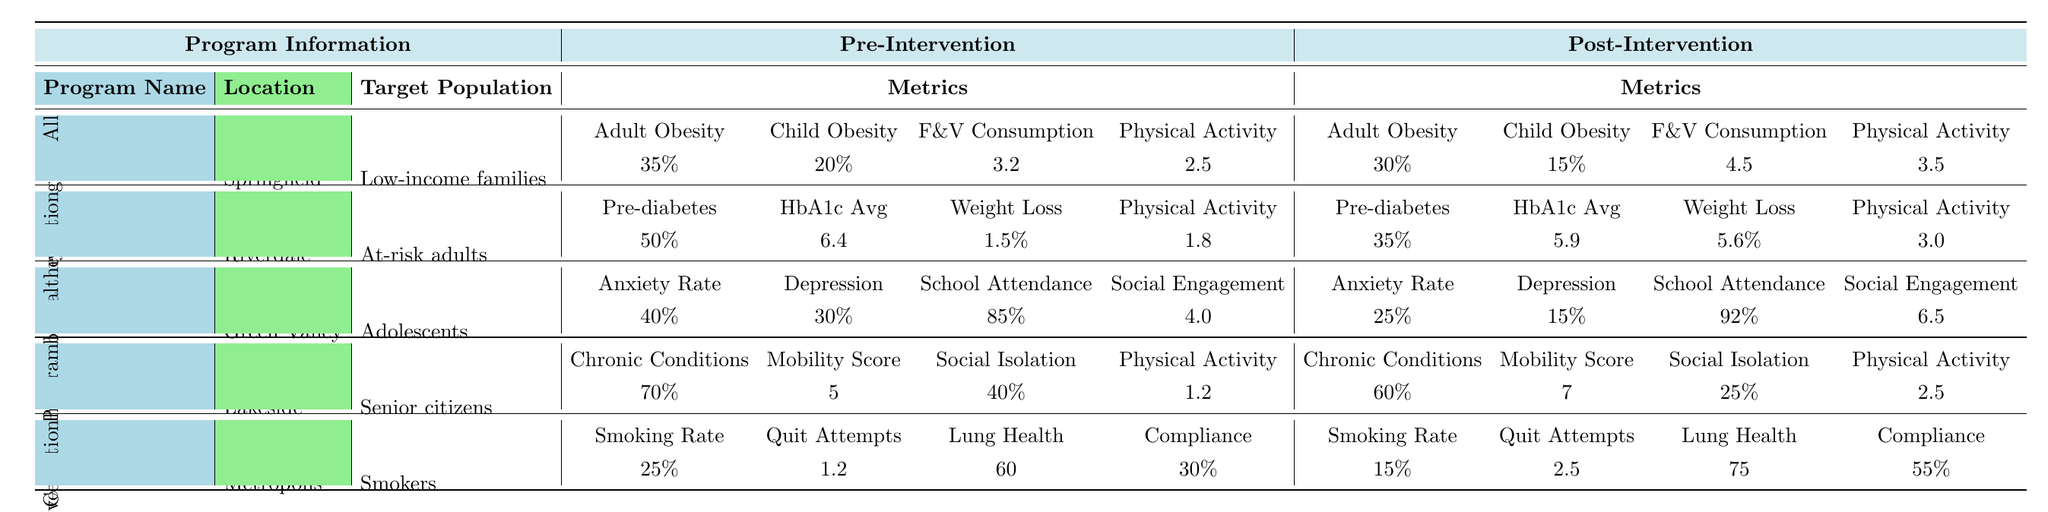What is the smoking rate before the Tobacco Cessation Initiative? The table shows the pre-intervention smoking rate for the Tobacco Cessation Initiative listed under "Pre-Intervention" metrics as 25%.
Answer: 25% What is the average physical activity level for participants in the Healthy Eating for All program after the intervention? In the table, the post-intervention physical activity level for the Healthy Eating for All program is 3.5, which is the only value needed to answer this question.
Answer: 3.5 Did the diabetes prevention program successfully reduce the pre-diabetes rate? The pre-diabetes rate went from 50% before the intervention to 35% afterwards, indicating a successful reduction.
Answer: Yes What was the change in child obesity rate from the Healthy Eating for All program? The child obesity rate decreased from 20% to 15%, so the change is 20% - 15% = 5%.
Answer: 5% Which program had the highest reduction in anxiety rate among adolescents? The Youth Mental Health Initiative had a reduction from 40% to 25%, a 15% decrease. No other program for adolescents is listed with a reduction.
Answer: Youth Mental Health Initiative What is the total percentage of chronic conditions for senior citizens after the Active Aging Program? The post-intervention chronic conditions rate is 60%, which is stated clearly in the table and is the only figure needed.
Answer: 60% Compare the fruit and vegetable consumption before and after the Healthy Eating for All program. The pre-intervention fruit and vegetable consumption was 3.2 servings, which improved to 4.5 servings post-intervention, leading to an increase of 4.5 - 3.2 = 1.3 servings.
Answer: 1.3 servings increase What percentage of smokers attempted to quit in the last year after the Tobacco Cessation Initiative? After the intervention, the table shows quit attempts increased to 2.5 on average, which is the relevant value for this question.
Answer: 2.5 Was the improvement in physical activity level for senior citizens significant after the Active Aging Program? The physical activity level increased from 1.2 to 2.5, indicating a positive change of 2.5 - 1.2 = 1.3, suggesting significant improvement.
Answer: Yes What is the depression rate for adolescents after the Youth Mental Health Initiative? In the post-intervention section for the Youth Mental Health Initiative, the depression rate is recorded as 15%.
Answer: 15% Which program had participants reporting the highest social engagement index after the intervention? The Youth Mental Health Initiative reported a social engagement index of 6.5, which is higher than the other programs.
Answer: Youth Mental Health Initiative 